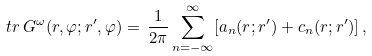<formula> <loc_0><loc_0><loc_500><loc_500>t r \, G ^ { \omega } ( r , \varphi ; r ^ { \prime } , \varphi ) = \, \frac { 1 } { 2 \pi } \sum _ { n = - \infty } ^ { \infty } [ a _ { n } ( r ; r ^ { \prime } ) + c _ { n } ( r ; r ^ { \prime } ) ] \, ,</formula> 